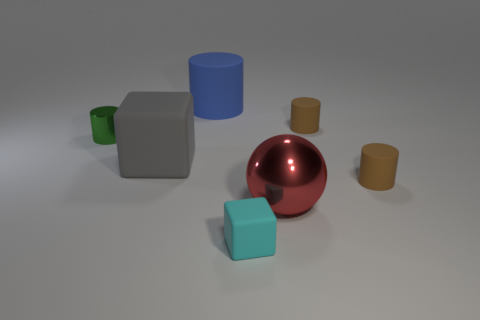Subtract all green metallic cylinders. How many cylinders are left? 3 Add 1 red spheres. How many objects exist? 8 Subtract all gray blocks. How many blocks are left? 1 Subtract 1 cylinders. How many cylinders are left? 3 Subtract all blue cylinders. How many gray cubes are left? 1 Subtract all big blue rubber cylinders. Subtract all big cylinders. How many objects are left? 5 Add 6 large blue things. How many large blue things are left? 7 Add 5 green objects. How many green objects exist? 6 Subtract 0 yellow cylinders. How many objects are left? 7 Subtract all spheres. How many objects are left? 6 